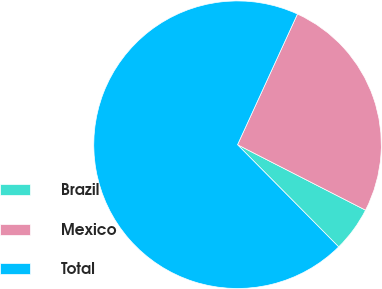Convert chart. <chart><loc_0><loc_0><loc_500><loc_500><pie_chart><fcel>Brazil<fcel>Mexico<fcel>Total<nl><fcel>5.06%<fcel>25.68%<fcel>69.26%<nl></chart> 